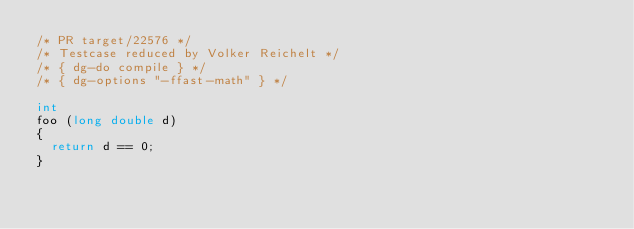Convert code to text. <code><loc_0><loc_0><loc_500><loc_500><_C_>/* PR target/22576 */
/* Testcase reduced by Volker Reichelt */
/* { dg-do compile } */
/* { dg-options "-ffast-math" } */

int
foo (long double d)
{
  return d == 0;
}
</code> 